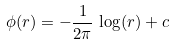Convert formula to latex. <formula><loc_0><loc_0><loc_500><loc_500>\phi ( r ) = - \frac { 1 } { 2 \pi } \, \log ( r ) + c</formula> 